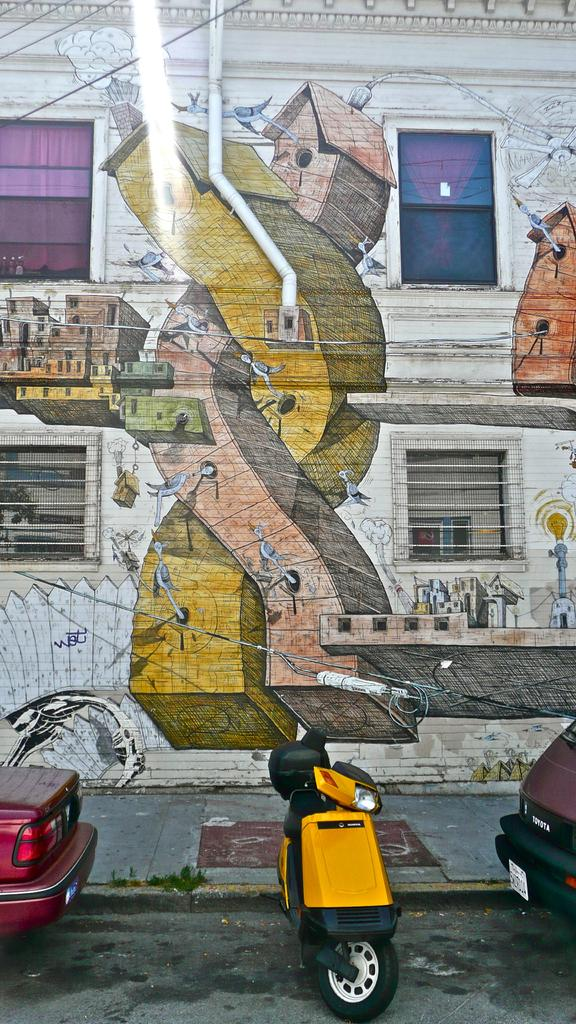What is the main subject in the center of the image? There are vehicles in the center of the image. What can be seen in the background of the image? There is a wall and windows in the background of the image. What is on the wall in the background? There is some artwork on the wall. Can you see a quilt hanging on the wall in the image? No, there is no quilt present in the image. How does the artwork on the wall look in the image? The question cannot be answered definitively as the appearance of the artwork is not described in the provided facts. 